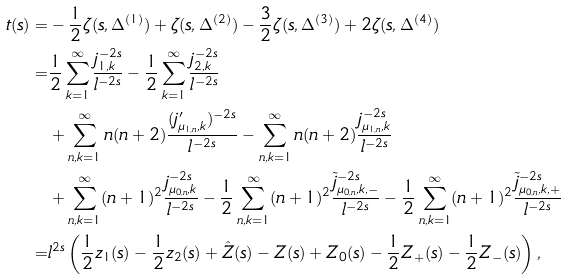<formula> <loc_0><loc_0><loc_500><loc_500>t ( s ) = & - \frac { 1 } { 2 } \zeta ( s , \Delta ^ { ( 1 ) } ) + \zeta ( s , \Delta ^ { ( 2 ) } ) - \frac { 3 } { 2 } \zeta ( s , \Delta ^ { ( 3 ) } ) + 2 \zeta ( s , \Delta ^ { ( 4 ) } ) \\ = & \frac { 1 } { 2 } \sum _ { k = 1 } ^ { \infty } \frac { j _ { 1 , k } ^ { - 2 s } } { l ^ { - 2 s } } - \frac { 1 } { 2 } \sum _ { k = 1 } ^ { \infty } \frac { j _ { 2 , k } ^ { - 2 s } } { l ^ { - 2 s } } \\ & + \sum _ { n , k = 1 } ^ { \infty } n ( n + 2 ) \frac { ( j ^ { \prime } _ { \mu _ { 1 , n } , k } ) ^ { - 2 s } } { l ^ { - 2 s } } - \sum _ { n , k = 1 } ^ { \infty } n ( n + 2 ) \frac { j _ { \mu _ { 1 , n } , k } ^ { - 2 s } } { l ^ { - 2 s } } \\ & + \sum _ { n , k = 1 } ^ { \infty } ( n + 1 ) ^ { 2 } \frac { j _ { \mu _ { 0 , n } , k } ^ { - 2 s } } { l ^ { - 2 s } } - \frac { 1 } { 2 } \sum _ { n , k = 1 } ^ { \infty } ( n + 1 ) ^ { 2 } \frac { \tilde { j } _ { \mu _ { 0 , n } , k , - } ^ { - 2 s } } { l ^ { - 2 s } } - \frac { 1 } { 2 } \sum _ { n , k = 1 } ^ { \infty } ( n + 1 ) ^ { 2 } \frac { \tilde { j } _ { \mu _ { 0 , n } , k , + } ^ { - 2 s } } { l ^ { - 2 s } } \\ = & l ^ { 2 s } \left ( \frac { 1 } { 2 } z _ { 1 } ( s ) - \frac { 1 } { 2 } z _ { 2 } ( s ) + \hat { Z } ( s ) - Z ( s ) + Z _ { 0 } ( s ) - \frac { 1 } { 2 } Z _ { + } ( s ) - \frac { 1 } { 2 } Z _ { - } ( s ) \right ) ,</formula> 